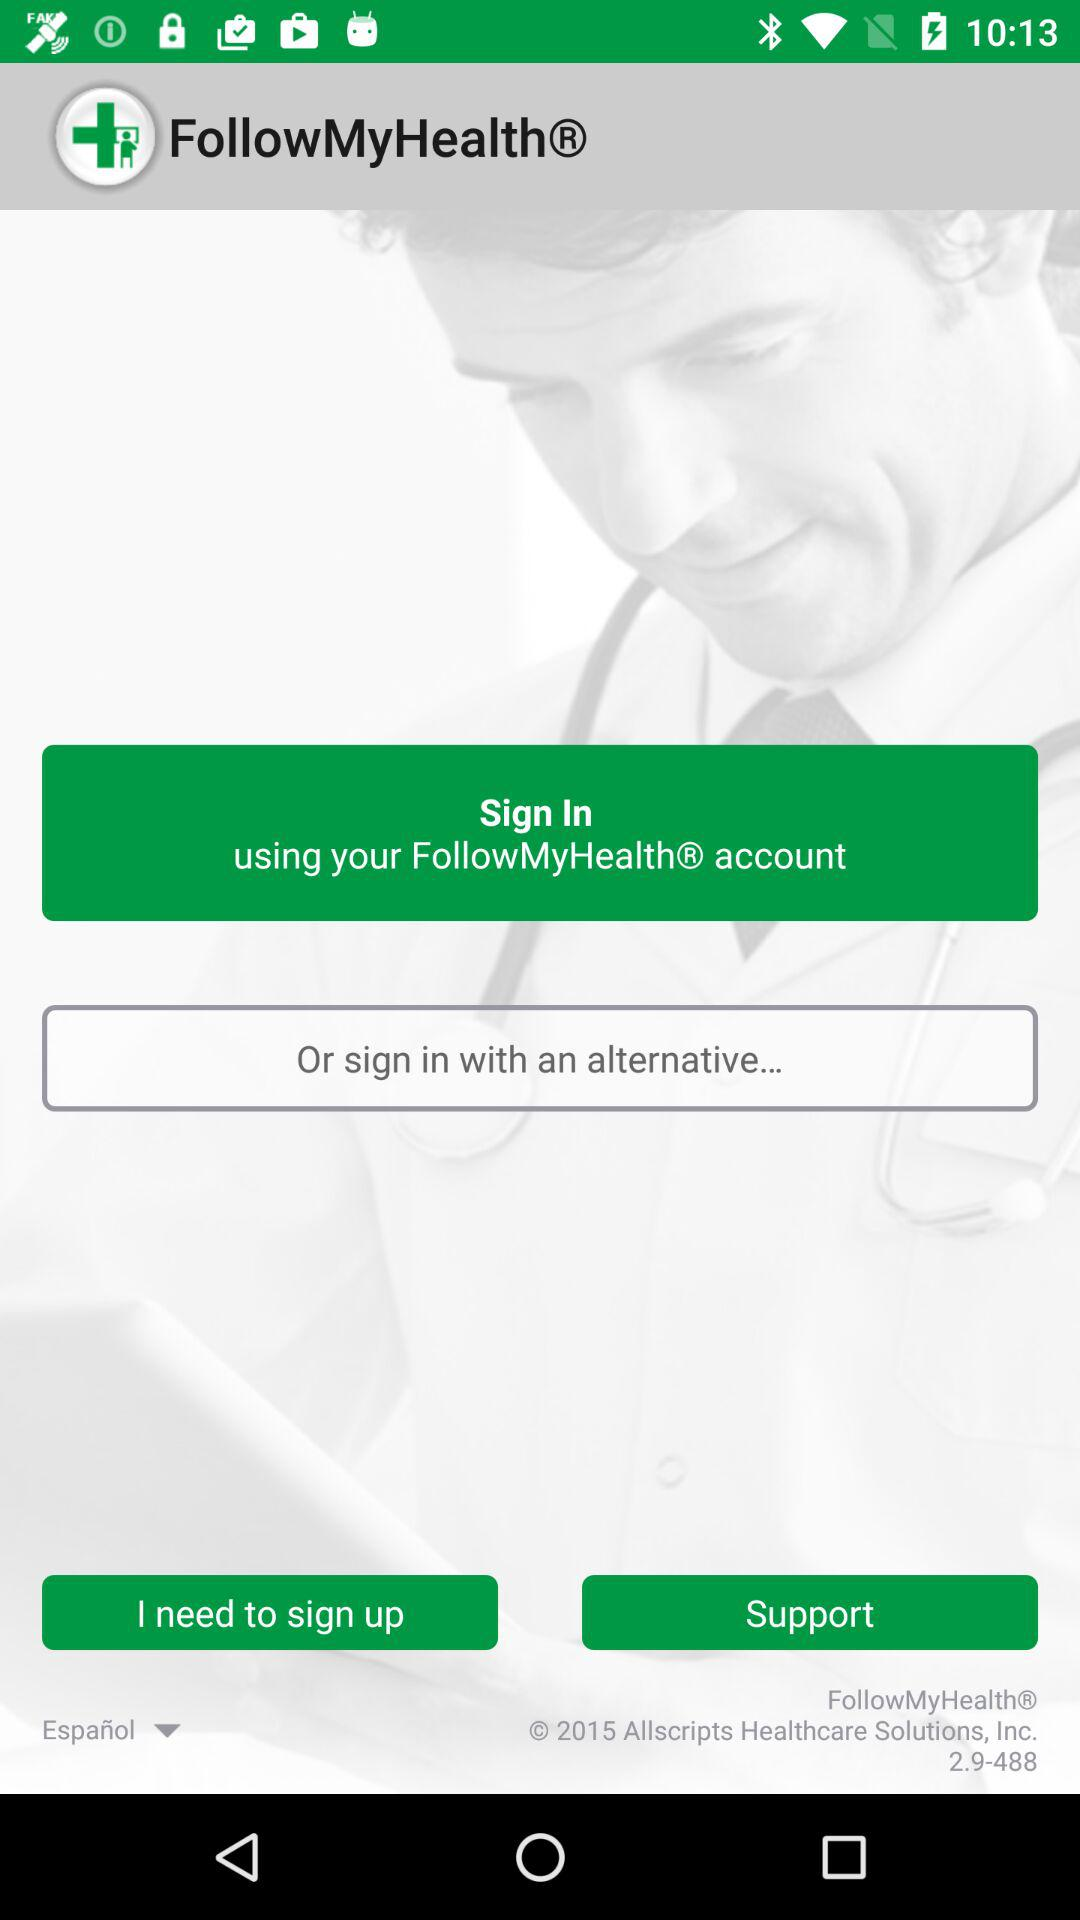What is the application version? The value is 2.9-488. 